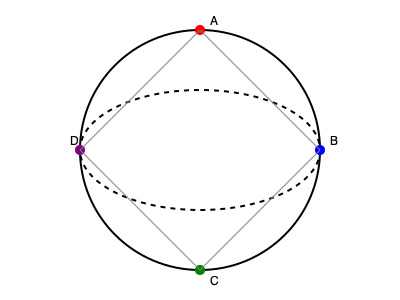Given the 2D projection of a communication satellite network orbiting Earth, which satellite configuration would provide the most efficient coverage for global diplomatic communications? Assume that each satellite can cover a 90-degree arc of the Earth's surface. To determine the most efficient satellite configuration for global diplomatic communications, we need to consider the following steps:

1. Understand the projection:
   - The circle represents Earth's equator.
   - The ellipse represents a geostationary orbit.
   - Satellites A, B, C, and D are positioned at different points in the orbit.

2. Consider coverage area:
   - Each satellite can cover a 90-degree arc (1/4 of Earth's surface).

3. Analyze configurations:
   - Two satellites at opposite ends of a diameter would cover 180 degrees.
   - Three satellites would cover 270 degrees but leave a gap.
   - Four satellites, evenly spaced, would provide complete 360-degree coverage.

4. Evaluate efficiency:
   - The most efficient configuration is one that provides complete global coverage with the minimum number of satellites.

5. Identify the optimal configuration:
   - Satellites positioned at A, B, C, and D form a square in the 2D projection.
   - This configuration represents four satellites evenly spaced around the Earth.
   - Each satellite covers a 90-degree arc, resulting in complete 360-degree coverage.

6. Consider diplomatic communication needs:
   - Global coverage is crucial for international diplomatic communications.
   - Redundancy in coverage helps ensure reliable communication.

Therefore, the most efficient configuration for global diplomatic communications is the one shown in the diagram, with satellites positioned at A, B, C, and D.
Answer: Four satellites at A, B, C, and D 